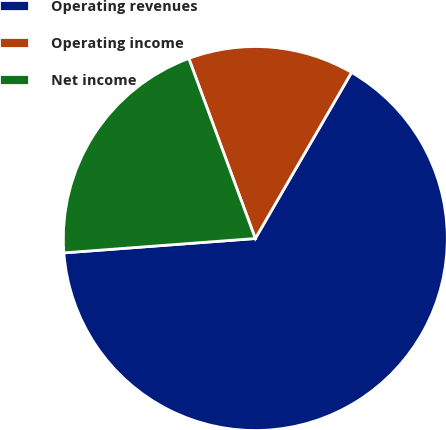<chart> <loc_0><loc_0><loc_500><loc_500><pie_chart><fcel>Operating revenues<fcel>Operating income<fcel>Net income<nl><fcel>65.45%<fcel>13.99%<fcel>20.56%<nl></chart> 